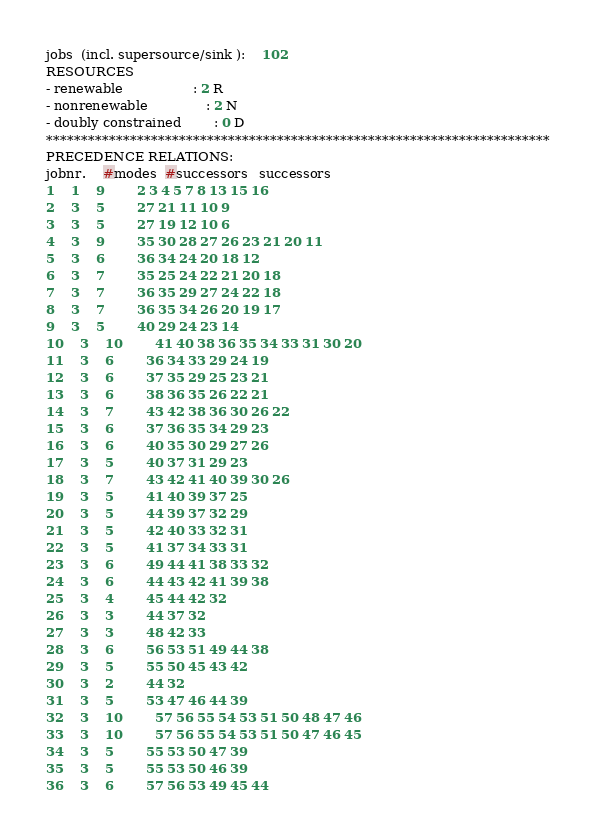Convert code to text. <code><loc_0><loc_0><loc_500><loc_500><_ObjectiveC_>jobs  (incl. supersource/sink ):	102
RESOURCES
- renewable                 : 2 R
- nonrenewable              : 2 N
- doubly constrained        : 0 D
************************************************************************
PRECEDENCE RELATIONS:
jobnr.    #modes  #successors   successors
1	1	9		2 3 4 5 7 8 13 15 16 
2	3	5		27 21 11 10 9 
3	3	5		27 19 12 10 6 
4	3	9		35 30 28 27 26 23 21 20 11 
5	3	6		36 34 24 20 18 12 
6	3	7		35 25 24 22 21 20 18 
7	3	7		36 35 29 27 24 22 18 
8	3	7		36 35 34 26 20 19 17 
9	3	5		40 29 24 23 14 
10	3	10		41 40 38 36 35 34 33 31 30 20 
11	3	6		36 34 33 29 24 19 
12	3	6		37 35 29 25 23 21 
13	3	6		38 36 35 26 22 21 
14	3	7		43 42 38 36 30 26 22 
15	3	6		37 36 35 34 29 23 
16	3	6		40 35 30 29 27 26 
17	3	5		40 37 31 29 23 
18	3	7		43 42 41 40 39 30 26 
19	3	5		41 40 39 37 25 
20	3	5		44 39 37 32 29 
21	3	5		42 40 33 32 31 
22	3	5		41 37 34 33 31 
23	3	6		49 44 41 38 33 32 
24	3	6		44 43 42 41 39 38 
25	3	4		45 44 42 32 
26	3	3		44 37 32 
27	3	3		48 42 33 
28	3	6		56 53 51 49 44 38 
29	3	5		55 50 45 43 42 
30	3	2		44 32 
31	3	5		53 47 46 44 39 
32	3	10		57 56 55 54 53 51 50 48 47 46 
33	3	10		57 56 55 54 53 51 50 47 46 45 
34	3	5		55 53 50 47 39 
35	3	5		55 53 50 46 39 
36	3	6		57 56 53 49 45 44 </code> 